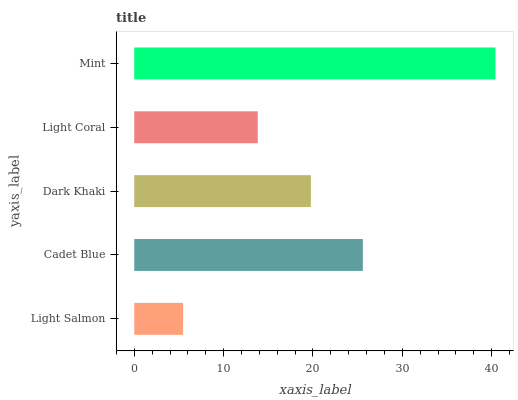Is Light Salmon the minimum?
Answer yes or no. Yes. Is Mint the maximum?
Answer yes or no. Yes. Is Cadet Blue the minimum?
Answer yes or no. No. Is Cadet Blue the maximum?
Answer yes or no. No. Is Cadet Blue greater than Light Salmon?
Answer yes or no. Yes. Is Light Salmon less than Cadet Blue?
Answer yes or no. Yes. Is Light Salmon greater than Cadet Blue?
Answer yes or no. No. Is Cadet Blue less than Light Salmon?
Answer yes or no. No. Is Dark Khaki the high median?
Answer yes or no. Yes. Is Dark Khaki the low median?
Answer yes or no. Yes. Is Light Coral the high median?
Answer yes or no. No. Is Light Coral the low median?
Answer yes or no. No. 